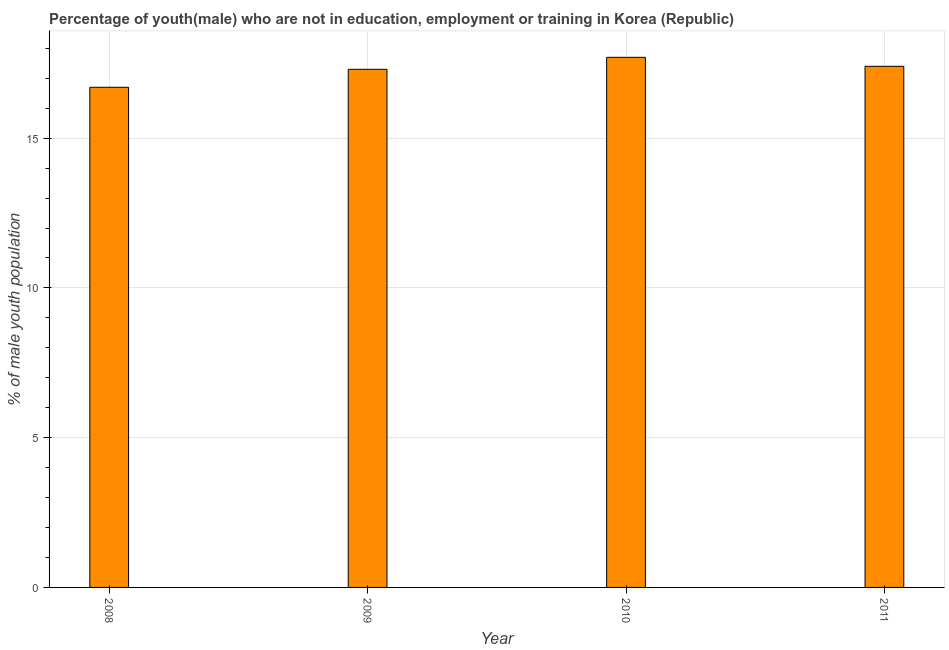Does the graph contain grids?
Give a very brief answer. Yes. What is the title of the graph?
Offer a terse response. Percentage of youth(male) who are not in education, employment or training in Korea (Republic). What is the label or title of the X-axis?
Give a very brief answer. Year. What is the label or title of the Y-axis?
Make the answer very short. % of male youth population. What is the unemployed male youth population in 2011?
Offer a terse response. 17.4. Across all years, what is the maximum unemployed male youth population?
Your response must be concise. 17.7. Across all years, what is the minimum unemployed male youth population?
Your answer should be compact. 16.7. In which year was the unemployed male youth population maximum?
Provide a short and direct response. 2010. In which year was the unemployed male youth population minimum?
Ensure brevity in your answer.  2008. What is the sum of the unemployed male youth population?
Keep it short and to the point. 69.1. What is the average unemployed male youth population per year?
Provide a succinct answer. 17.27. What is the median unemployed male youth population?
Give a very brief answer. 17.35. In how many years, is the unemployed male youth population greater than 13 %?
Make the answer very short. 4. What is the ratio of the unemployed male youth population in 2009 to that in 2011?
Offer a very short reply. 0.99. Is the unemployed male youth population in 2008 less than that in 2011?
Give a very brief answer. Yes. Is the difference between the unemployed male youth population in 2008 and 2009 greater than the difference between any two years?
Give a very brief answer. No. What is the difference between the highest and the lowest unemployed male youth population?
Your answer should be very brief. 1. Are all the bars in the graph horizontal?
Make the answer very short. No. How many years are there in the graph?
Your response must be concise. 4. What is the difference between two consecutive major ticks on the Y-axis?
Your answer should be very brief. 5. What is the % of male youth population of 2008?
Offer a very short reply. 16.7. What is the % of male youth population of 2009?
Your answer should be very brief. 17.3. What is the % of male youth population in 2010?
Provide a short and direct response. 17.7. What is the % of male youth population in 2011?
Keep it short and to the point. 17.4. What is the difference between the % of male youth population in 2008 and 2011?
Keep it short and to the point. -0.7. What is the difference between the % of male youth population in 2009 and 2010?
Your response must be concise. -0.4. What is the difference between the % of male youth population in 2009 and 2011?
Ensure brevity in your answer.  -0.1. What is the difference between the % of male youth population in 2010 and 2011?
Ensure brevity in your answer.  0.3. What is the ratio of the % of male youth population in 2008 to that in 2009?
Ensure brevity in your answer.  0.96. What is the ratio of the % of male youth population in 2008 to that in 2010?
Your answer should be very brief. 0.94. What is the ratio of the % of male youth population in 2010 to that in 2011?
Your response must be concise. 1.02. 